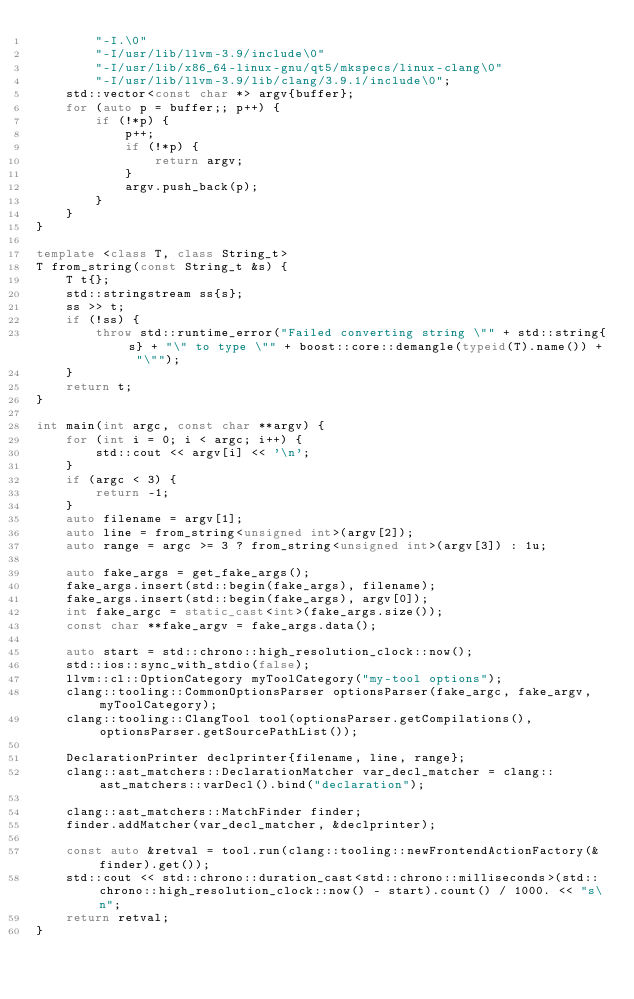<code> <loc_0><loc_0><loc_500><loc_500><_C++_>		"-I.\0"
		"-I/usr/lib/llvm-3.9/include\0"
		"-I/usr/lib/x86_64-linux-gnu/qt5/mkspecs/linux-clang\0"
		"-I/usr/lib/llvm-3.9/lib/clang/3.9.1/include\0";
	std::vector<const char *> argv{buffer};
	for (auto p = buffer;; p++) {
		if (!*p) {
			p++;
			if (!*p) {
				return argv;
			}
			argv.push_back(p);
		}
	}
}

template <class T, class String_t>
T from_string(const String_t &s) {
	T t{};
	std::stringstream ss{s};
	ss >> t;
	if (!ss) {
		throw std::runtime_error("Failed converting string \"" + std::string{s} + "\" to type \"" + boost::core::demangle(typeid(T).name()) + "\"");
	}
	return t;
}

int main(int argc, const char **argv) {
	for (int i = 0; i < argc; i++) {
		std::cout << argv[i] << '\n';
	}
	if (argc < 3) {
		return -1;
	}
	auto filename = argv[1];
	auto line = from_string<unsigned int>(argv[2]);
	auto range = argc >= 3 ? from_string<unsigned int>(argv[3]) : 1u;

	auto fake_args = get_fake_args();
	fake_args.insert(std::begin(fake_args), filename);
	fake_args.insert(std::begin(fake_args), argv[0]);
	int fake_argc = static_cast<int>(fake_args.size());
	const char **fake_argv = fake_args.data();

	auto start = std::chrono::high_resolution_clock::now();
	std::ios::sync_with_stdio(false);
	llvm::cl::OptionCategory myToolCategory("my-tool options");
	clang::tooling::CommonOptionsParser optionsParser(fake_argc, fake_argv, myToolCategory);
	clang::tooling::ClangTool tool(optionsParser.getCompilations(), optionsParser.getSourcePathList());

	DeclarationPrinter declprinter{filename, line, range};
	clang::ast_matchers::DeclarationMatcher var_decl_matcher = clang::ast_matchers::varDecl().bind("declaration");

	clang::ast_matchers::MatchFinder finder;
	finder.addMatcher(var_decl_matcher, &declprinter);

	const auto &retval = tool.run(clang::tooling::newFrontendActionFactory(&finder).get());
	std::cout << std::chrono::duration_cast<std::chrono::milliseconds>(std::chrono::high_resolution_clock::now() - start).count() / 1000. << "s\n";
	return retval;
}
</code> 